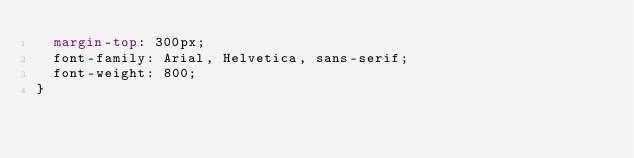Convert code to text. <code><loc_0><loc_0><loc_500><loc_500><_CSS_>  margin-top: 300px;
  font-family: Arial, Helvetica, sans-serif;
  font-weight: 800;
}
</code> 